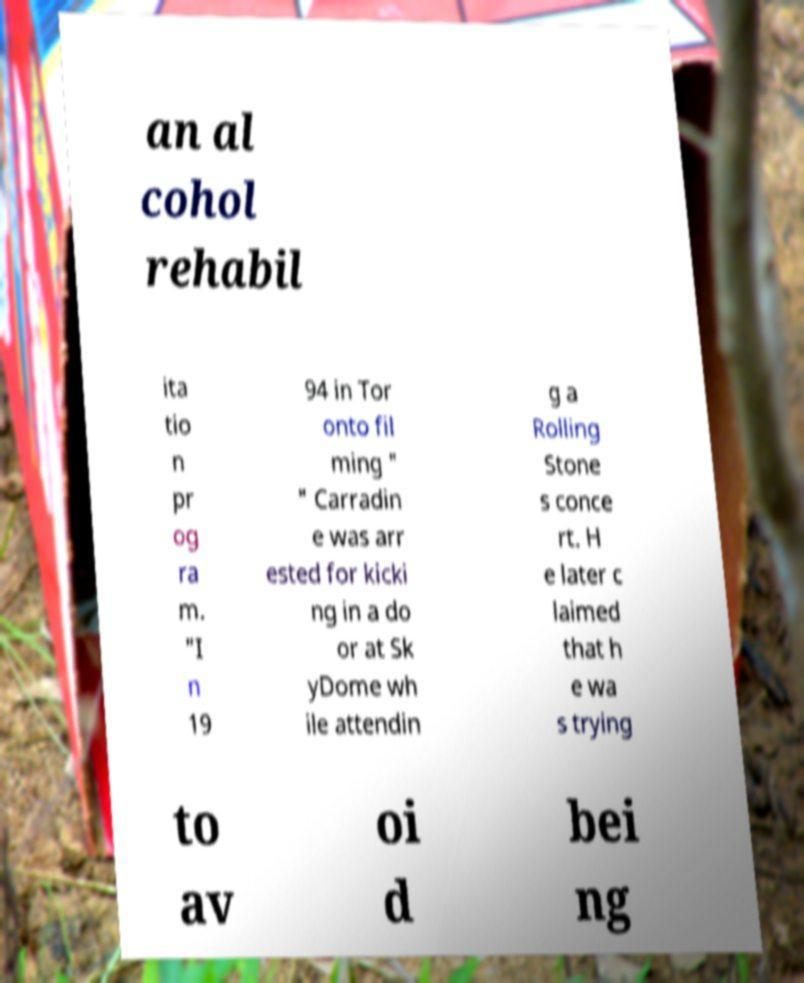What messages or text are displayed in this image? I need them in a readable, typed format. an al cohol rehabil ita tio n pr og ra m. "I n 19 94 in Tor onto fil ming " " Carradin e was arr ested for kicki ng in a do or at Sk yDome wh ile attendin g a Rolling Stone s conce rt. H e later c laimed that h e wa s trying to av oi d bei ng 